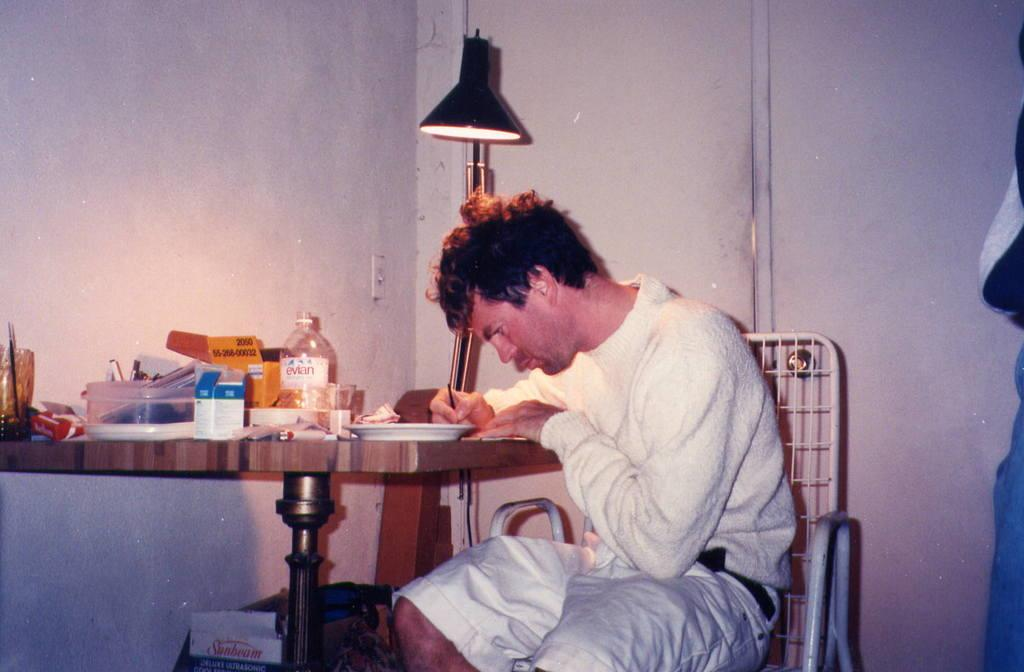What is the color of the wall in the image? The wall in the image is white. What object can be seen providing light in the image? There is a lamp in the image. What is the man in the image doing? The man is sitting on chairs in the image. What furniture is present in the image? There is a table in the image. What items are on the table in the image? There is a plate, a bottle, a glass, and a box on the table in the image. Can you see a kite being flown by the man in the image? No, there is no kite present in the image. Is the man's family also in the image? The provided facts do not mention any family members, so we cannot determine if they are present in the image. 